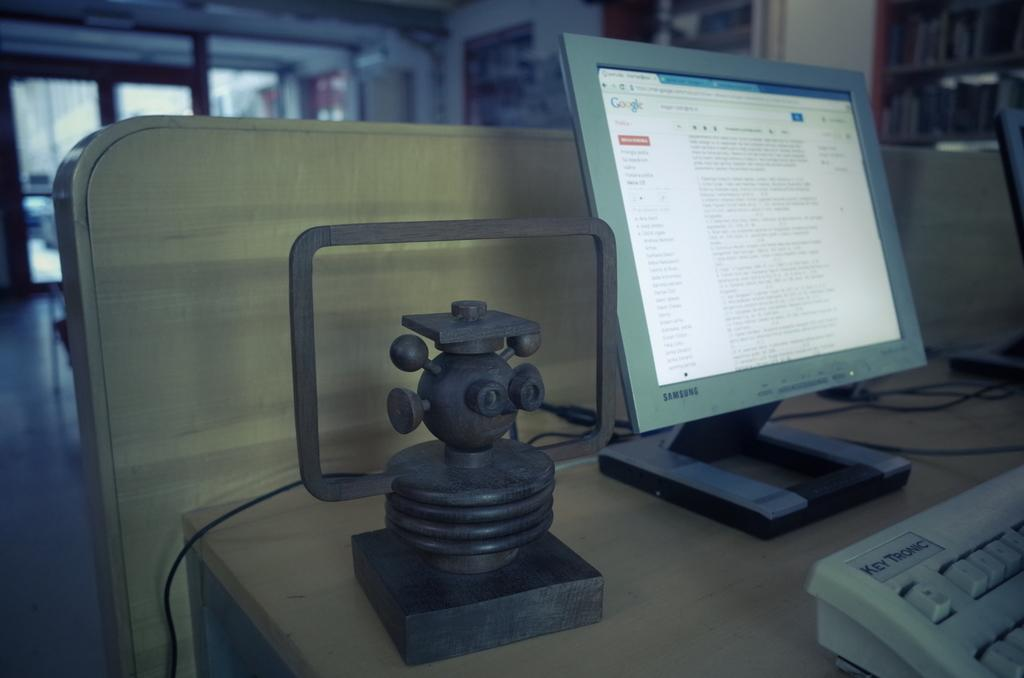Provide a one-sentence caption for the provided image. A gray Samsung monitor with the web-page Google open. 